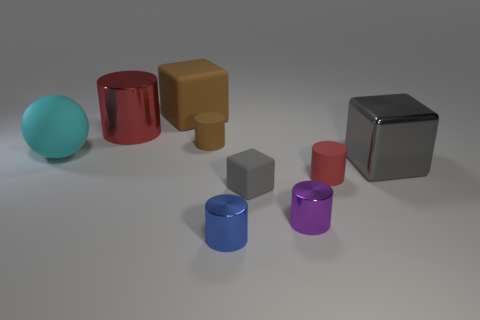Subtract all brown cylinders. How many cylinders are left? 4 Subtract all brown cylinders. How many cylinders are left? 4 Subtract all green cylinders. Subtract all yellow blocks. How many cylinders are left? 5 Add 1 large blue shiny objects. How many objects exist? 10 Subtract all blocks. How many objects are left? 6 Add 2 cyan things. How many cyan things exist? 3 Subtract 0 green cylinders. How many objects are left? 9 Subtract all gray metal cubes. Subtract all tiny blue metallic blocks. How many objects are left? 8 Add 4 blue things. How many blue things are left? 5 